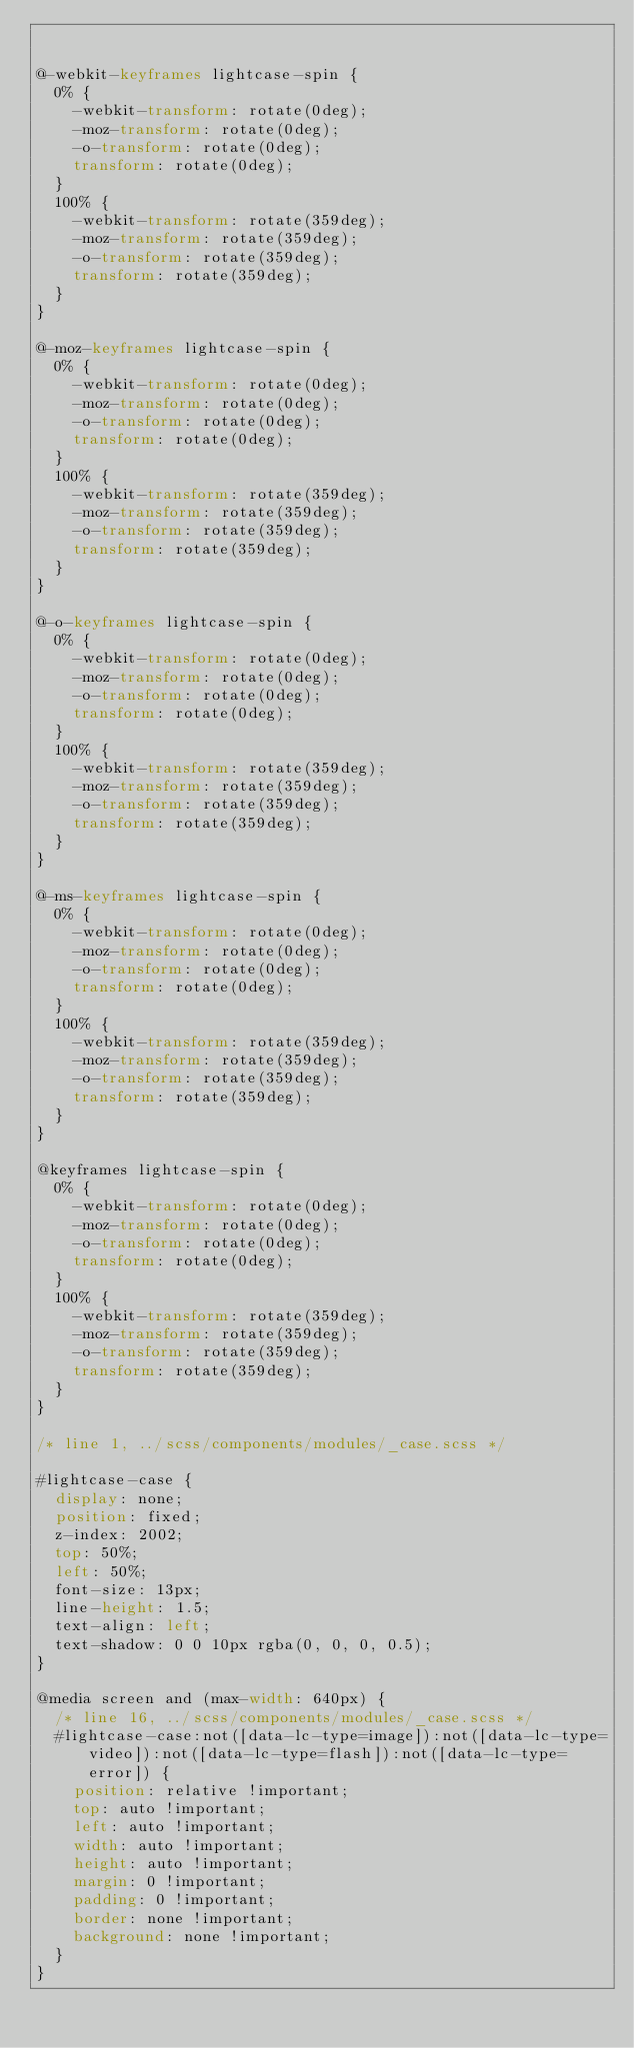<code> <loc_0><loc_0><loc_500><loc_500><_CSS_>

@-webkit-keyframes lightcase-spin {
  0% {
    -webkit-transform: rotate(0deg);
    -moz-transform: rotate(0deg);
    -o-transform: rotate(0deg);
    transform: rotate(0deg);
  }
  100% {
    -webkit-transform: rotate(359deg);
    -moz-transform: rotate(359deg);
    -o-transform: rotate(359deg);
    transform: rotate(359deg);
  }
}

@-moz-keyframes lightcase-spin {
  0% {
    -webkit-transform: rotate(0deg);
    -moz-transform: rotate(0deg);
    -o-transform: rotate(0deg);
    transform: rotate(0deg);
  }
  100% {
    -webkit-transform: rotate(359deg);
    -moz-transform: rotate(359deg);
    -o-transform: rotate(359deg);
    transform: rotate(359deg);
  }
}

@-o-keyframes lightcase-spin {
  0% {
    -webkit-transform: rotate(0deg);
    -moz-transform: rotate(0deg);
    -o-transform: rotate(0deg);
    transform: rotate(0deg);
  }
  100% {
    -webkit-transform: rotate(359deg);
    -moz-transform: rotate(359deg);
    -o-transform: rotate(359deg);
    transform: rotate(359deg);
  }
}

@-ms-keyframes lightcase-spin {
  0% {
    -webkit-transform: rotate(0deg);
    -moz-transform: rotate(0deg);
    -o-transform: rotate(0deg);
    transform: rotate(0deg);
  }
  100% {
    -webkit-transform: rotate(359deg);
    -moz-transform: rotate(359deg);
    -o-transform: rotate(359deg);
    transform: rotate(359deg);
  }
}

@keyframes lightcase-spin {
  0% {
    -webkit-transform: rotate(0deg);
    -moz-transform: rotate(0deg);
    -o-transform: rotate(0deg);
    transform: rotate(0deg);
  }
  100% {
    -webkit-transform: rotate(359deg);
    -moz-transform: rotate(359deg);
    -o-transform: rotate(359deg);
    transform: rotate(359deg);
  }
}

/* line 1, ../scss/components/modules/_case.scss */

#lightcase-case {
  display: none;
  position: fixed;
  z-index: 2002;
  top: 50%;
  left: 50%;
  font-size: 13px;
  line-height: 1.5;
  text-align: left;
  text-shadow: 0 0 10px rgba(0, 0, 0, 0.5);
}

@media screen and (max-width: 640px) {
  /* line 16, ../scss/components/modules/_case.scss */
  #lightcase-case:not([data-lc-type=image]):not([data-lc-type=video]):not([data-lc-type=flash]):not([data-lc-type=error]) {
    position: relative !important;
    top: auto !important;
    left: auto !important;
    width: auto !important;
    height: auto !important;
    margin: 0 !important;
    padding: 0 !important;
    border: none !important;
    background: none !important;
  }
}
</code> 